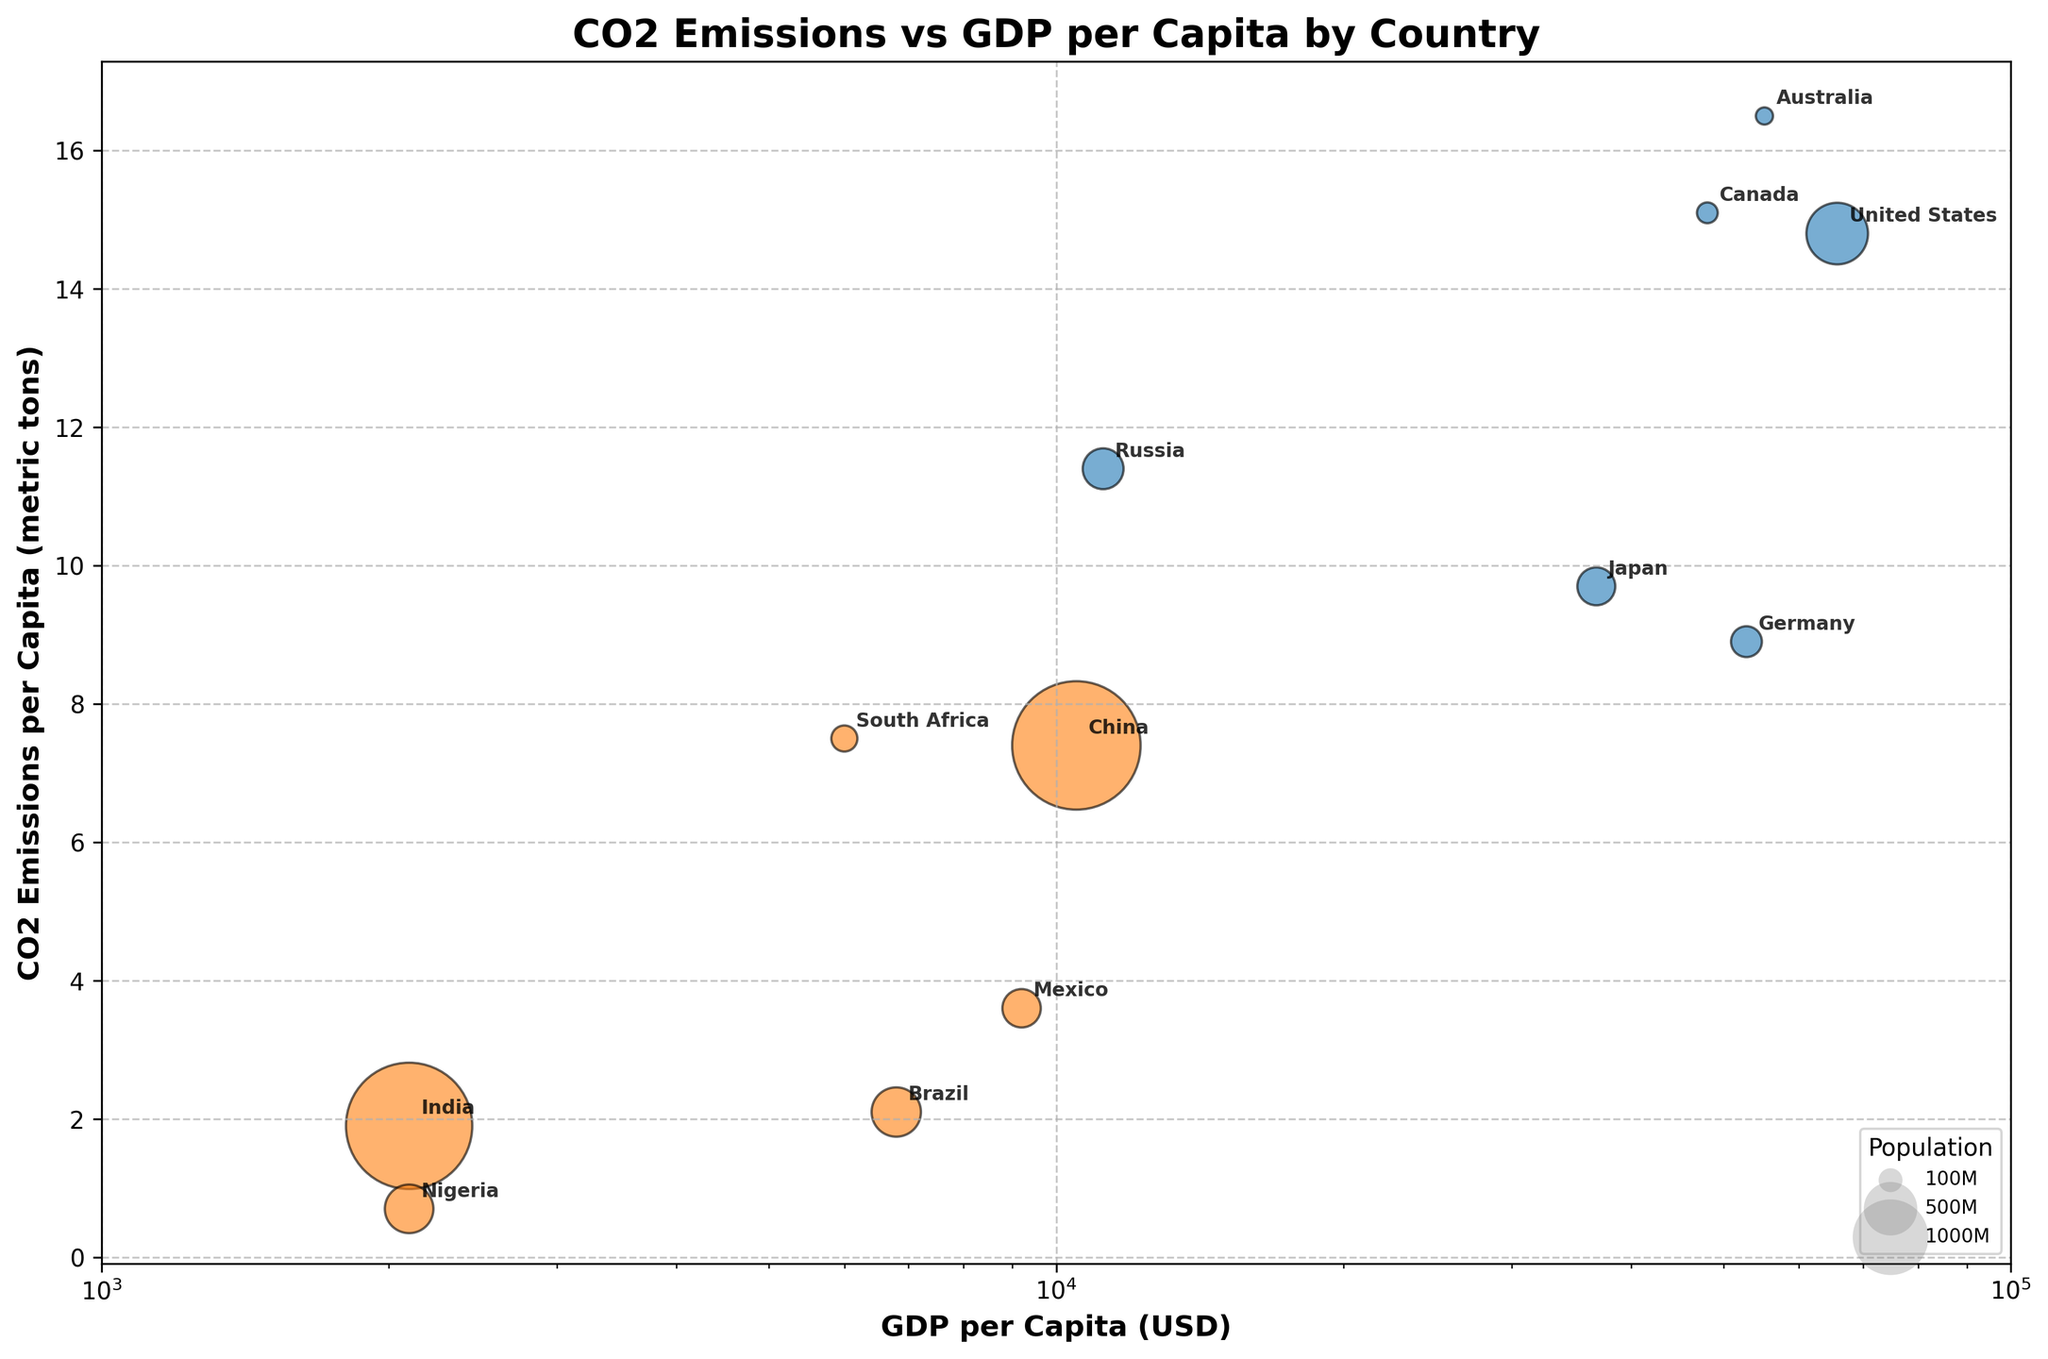What is the title of the chart? The title of the chart is typically displayed at the top and describes the main theme of the visualized data. In this figure, the title is "CO2 Emissions vs GDP per Capita by Country".
Answer: CO2 Emissions vs GDP per Capita by Country Which country has the largest population in the chart? The size of the bubbles represents the population size. The largest bubble corresponds to China, whose data point shows it has the largest population among the countries listed.
Answer: China What color represents developing countries in the chart? The chart uses different colors to differentiate between developed and developing countries. The developing countries are represented by the orange color in the figure.
Answer: Orange For which country does CO2 emissions per capita exceed 16 metric tons? To identify the country with CO2 emissions per capita exceeding 16 metric tons, look at the vertical axis and find the data points placed above the 16 metric ton mark. Australia has CO2 emissions per capita of 16.5 metric tons.
Answer: Australia Which country has the smallest CO2 emissions per capita and what is its value? By looking at the vertical axis and identifying the data point plotted lowest on that axis, Nigeria emerges as the country with the smallest CO2 emissions per capita of 0.7 metric tons.
Answer: Nigeria, 0.7 metric tons What is the range of GDP per capita represented on the x-axis? The x-axis represents GDP per capita in USD, using a logarithmic scale from 1000 to 100000. This range can be seen by inspecting the axis limits.
Answer: 1000 to 100000 USD Which countries have CO2 emissions per capita between 7 and 10 metric tons? Inspect the vertical axis to find data points between 7 and 10 metric tons. These points are associated with Germany (8.9), China (7.4), Japan (9.7), and South Africa (7.5).
Answer: Germany, China, Japan, South Africa Compare the CO2 emissions per capita of the United States and Canada. Which country has higher emissions? Locate the data points for the United States and Canada on the vertical axis representing CO2 emissions per capita. The United States has emissions of 14.8 metric tons, and Canada has 15.1 metric tons, so Canada has higher emissions.
Answer: Canada What is the general trend between GDP per capita and CO2 emissions per capita in developed countries? For developed countries, there is generally an upward trend where higher GDP per capita often correlates with higher CO2 emissions per capita. This can be observed by looking at the data points for developed countries.
Answer: Positive correlation How does the CO2 emissions per capita of Russia compare to that of India? The vertical positions of Russia's and India's data points need to be compared. Russia has CO2 emissions per capita of 11.4 metric tons, whereas India has 1.9 metric tons. This shows that Russia's emissions are much higher than India's.
Answer: Russia's emissions are higher 